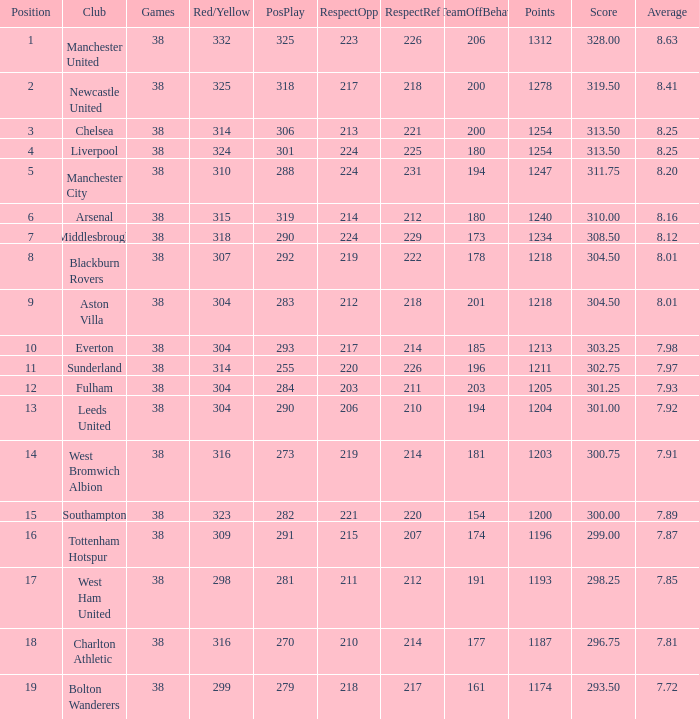Specify the elements for 212 consideration towards rivals. 1218.0. 